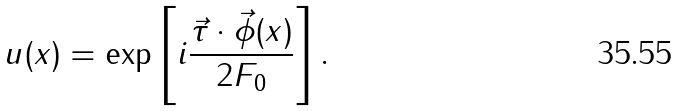<formula> <loc_0><loc_0><loc_500><loc_500>u ( x ) = \exp \left [ i \frac { \vec { \tau } \cdot \vec { \phi } ( x ) } { 2 F _ { 0 } } \right ] .</formula> 